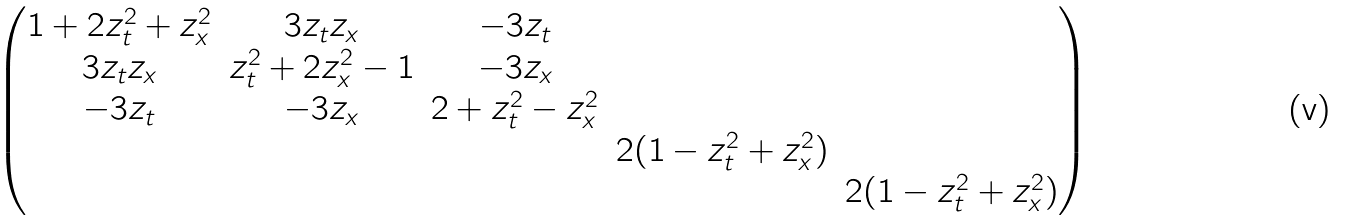<formula> <loc_0><loc_0><loc_500><loc_500>\begin{pmatrix} 1 + 2 z _ { t } ^ { 2 } + z _ { x } ^ { 2 } & 3 z _ { t } z _ { x } & - 3 z _ { t } & & \\ 3 z _ { t } z _ { x } & z _ { t } ^ { 2 } + 2 z _ { x } ^ { 2 } - 1 & - 3 z _ { x } & & \\ - 3 z _ { t } & - 3 z _ { x } & 2 + z _ { t } ^ { 2 } - z _ { x } ^ { 2 } & & \\ & & & 2 ( 1 - z _ { t } ^ { 2 } + z _ { x } ^ { 2 } ) & \\ & & & & 2 ( 1 - z _ { t } ^ { 2 } + z _ { x } ^ { 2 } ) \end{pmatrix}</formula> 